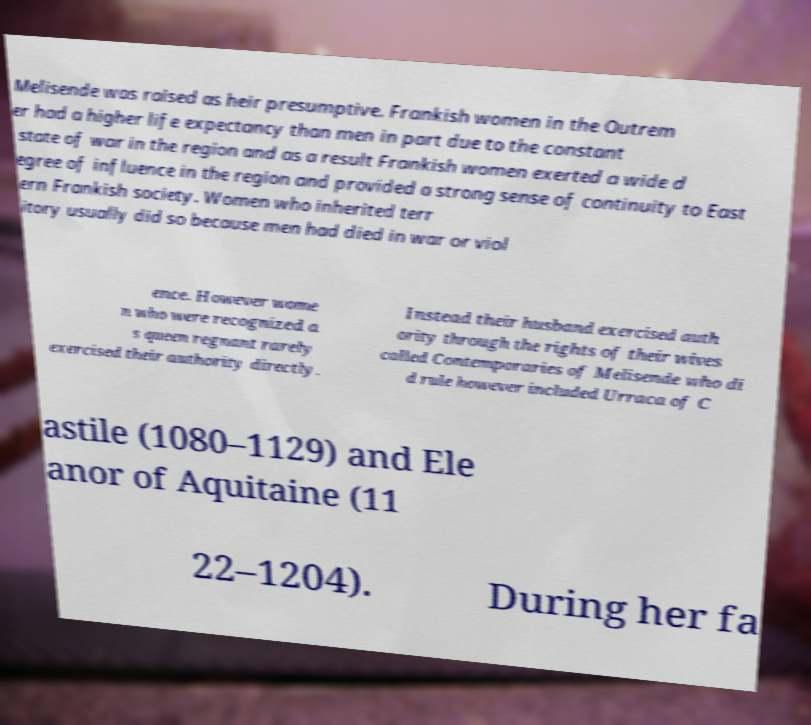Please read and relay the text visible in this image. What does it say? Melisende was raised as heir presumptive. Frankish women in the Outrem er had a higher life expectancy than men in part due to the constant state of war in the region and as a result Frankish women exerted a wide d egree of influence in the region and provided a strong sense of continuity to East ern Frankish society. Women who inherited terr itory usually did so because men had died in war or viol ence. However wome n who were recognized a s queen regnant rarely exercised their authority directly. Instead their husband exercised auth ority through the rights of their wives called Contemporaries of Melisende who di d rule however included Urraca of C astile (1080–1129) and Ele anor of Aquitaine (11 22–1204). During her fa 